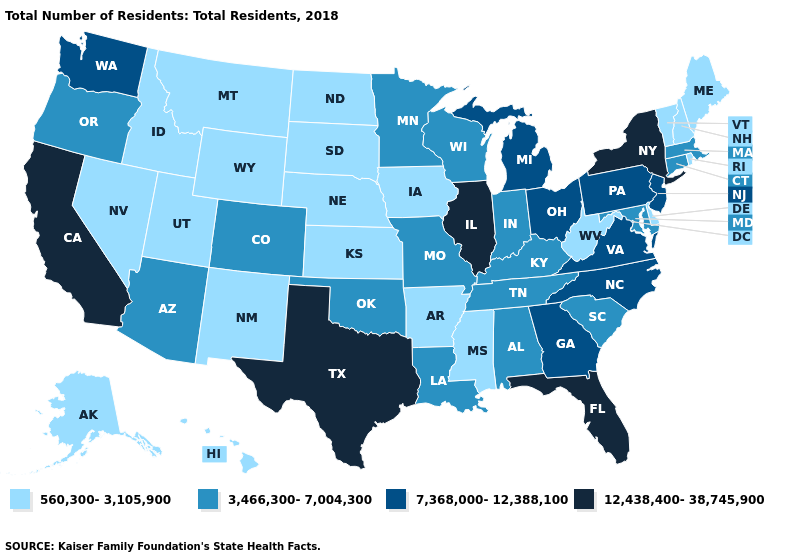Name the states that have a value in the range 12,438,400-38,745,900?
Give a very brief answer. California, Florida, Illinois, New York, Texas. Does New Jersey have the same value as Wyoming?
Concise answer only. No. What is the value of Louisiana?
Be succinct. 3,466,300-7,004,300. Name the states that have a value in the range 560,300-3,105,900?
Keep it brief. Alaska, Arkansas, Delaware, Hawaii, Idaho, Iowa, Kansas, Maine, Mississippi, Montana, Nebraska, Nevada, New Hampshire, New Mexico, North Dakota, Rhode Island, South Dakota, Utah, Vermont, West Virginia, Wyoming. What is the highest value in the USA?
Keep it brief. 12,438,400-38,745,900. Does Michigan have the highest value in the MidWest?
Keep it brief. No. What is the value of Arizona?
Write a very short answer. 3,466,300-7,004,300. What is the value of Arizona?
Answer briefly. 3,466,300-7,004,300. What is the value of Florida?
Short answer required. 12,438,400-38,745,900. What is the highest value in the MidWest ?
Answer briefly. 12,438,400-38,745,900. Does Delaware have the highest value in the USA?
Write a very short answer. No. Does North Carolina have the highest value in the USA?
Give a very brief answer. No. Does the first symbol in the legend represent the smallest category?
Answer briefly. Yes. Among the states that border Nebraska , which have the lowest value?
Write a very short answer. Iowa, Kansas, South Dakota, Wyoming. What is the value of Michigan?
Quick response, please. 7,368,000-12,388,100. 